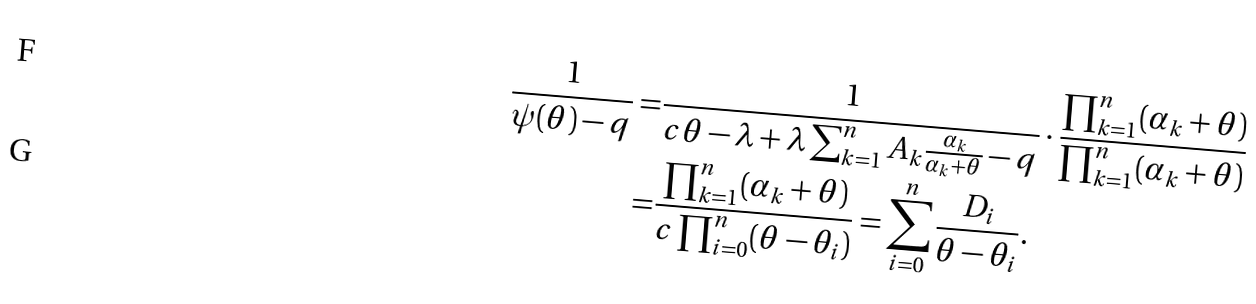Convert formula to latex. <formula><loc_0><loc_0><loc_500><loc_500>\frac { 1 } { \psi ( \theta ) - q } = & \frac { 1 } { c \theta - \lambda + \lambda \sum _ { k = 1 } ^ { n } A _ { k } \frac { \alpha _ { k } } { \alpha _ { k } + \theta } - q } \cdot \frac { \prod _ { k = 1 } ^ { n } ( \alpha _ { k } + \theta ) } { \prod _ { k = 1 } ^ { n } ( \alpha _ { k } + \theta ) } \\ = & \frac { \prod _ { k = 1 } ^ { n } ( \alpha _ { k } + \theta ) } { c \prod _ { i = 0 } ^ { n } ( \theta - \theta _ { i } ) } = \sum _ { i = 0 } ^ { n } \frac { D _ { i } } { \theta - \theta _ { i } } .</formula> 